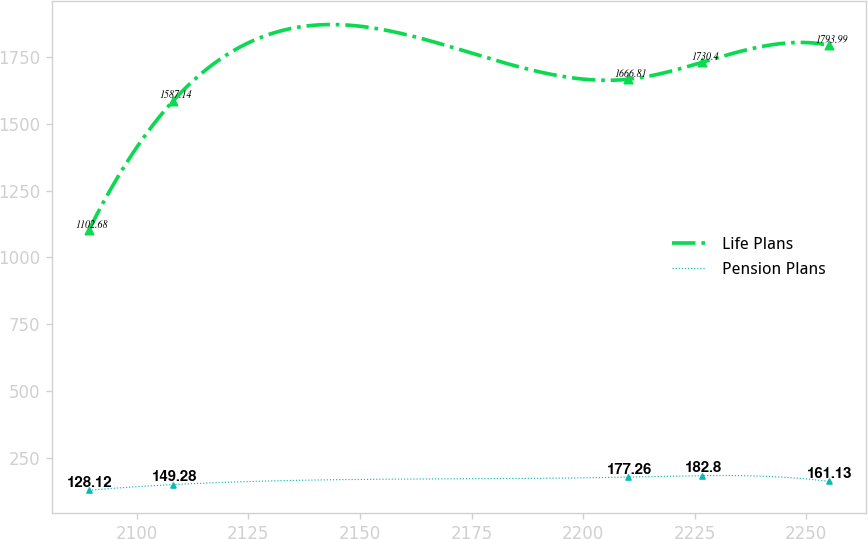Convert chart to OTSL. <chart><loc_0><loc_0><loc_500><loc_500><line_chart><ecel><fcel>Life Plans<fcel>Pension Plans<nl><fcel>2089.27<fcel>1102.68<fcel>128.12<nl><fcel>2108.2<fcel>1587.14<fcel>149.28<nl><fcel>2210.16<fcel>1666.81<fcel>177.26<nl><fcel>2226.74<fcel>1730.4<fcel>182.8<nl><fcel>2255.11<fcel>1793.99<fcel>161.13<nl></chart> 